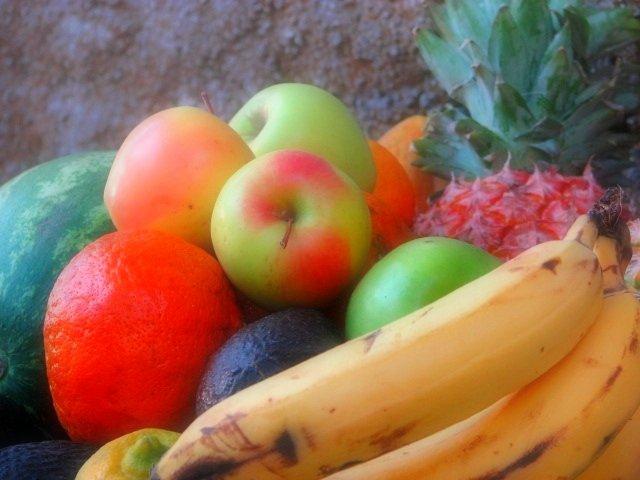Are the bananas ripe?
Keep it brief. Yes. Which fruit must be scored to make a pie?
Short answer required. Apple. Is there a watermelon next to the apples?
Write a very short answer. Yes. 